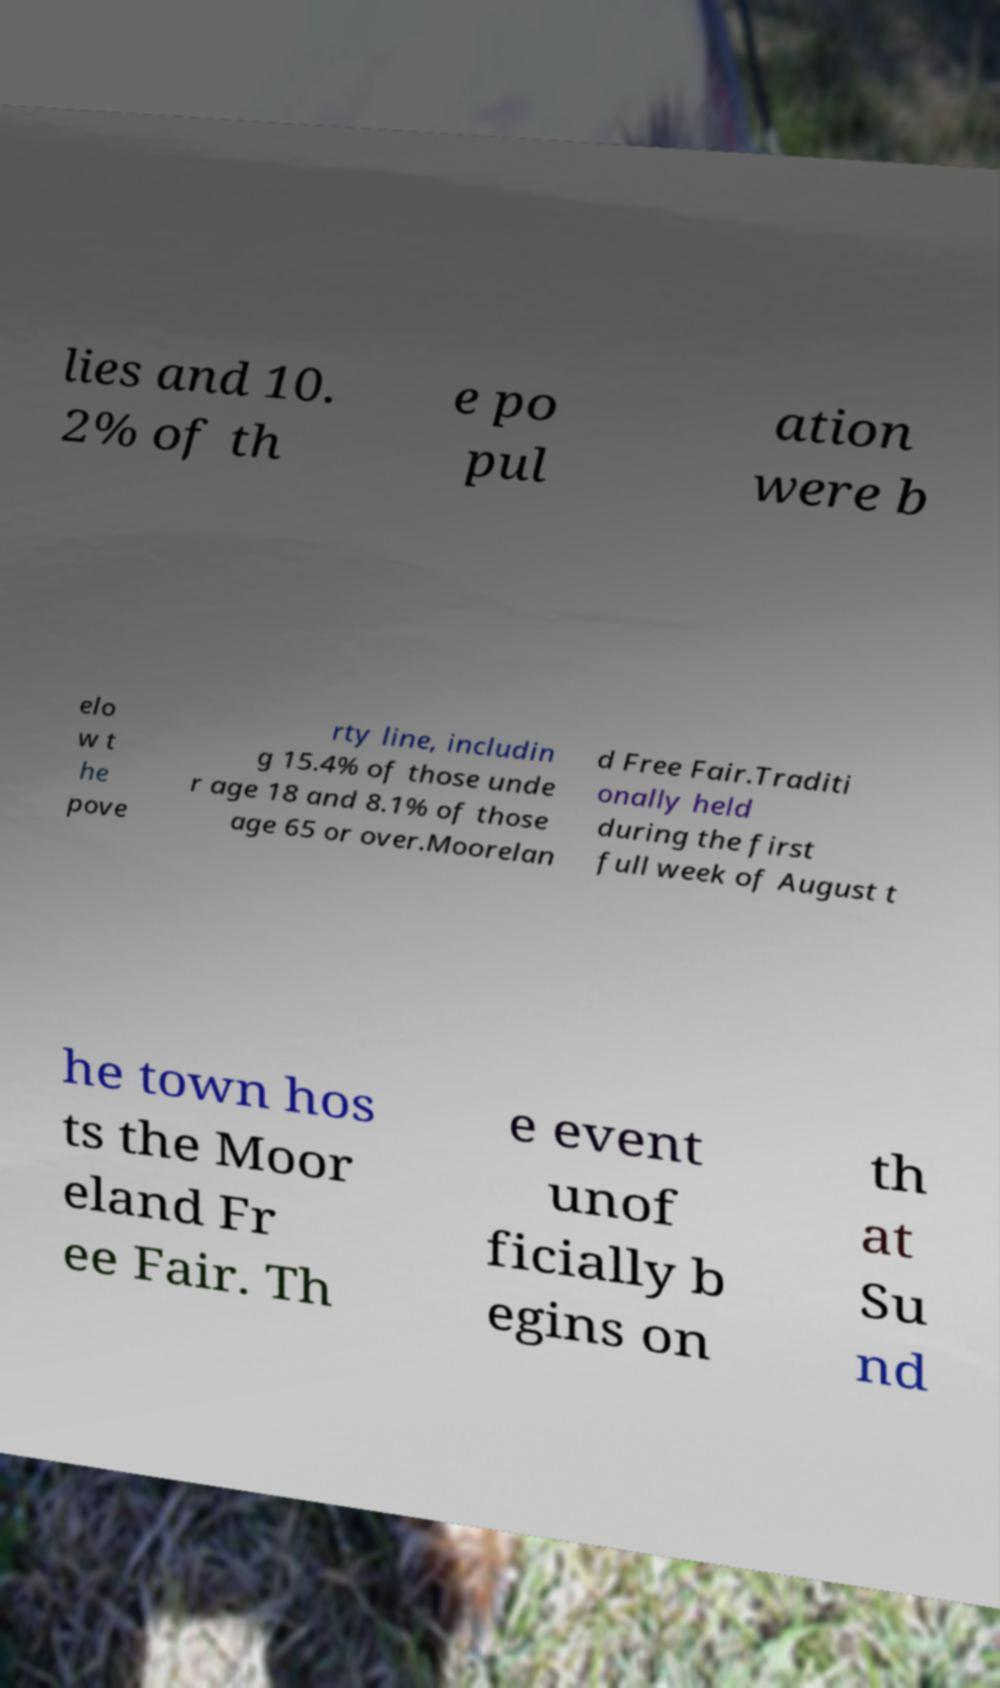I need the written content from this picture converted into text. Can you do that? lies and 10. 2% of th e po pul ation were b elo w t he pove rty line, includin g 15.4% of those unde r age 18 and 8.1% of those age 65 or over.Moorelan d Free Fair.Traditi onally held during the first full week of August t he town hos ts the Moor eland Fr ee Fair. Th e event unof ficially b egins on th at Su nd 